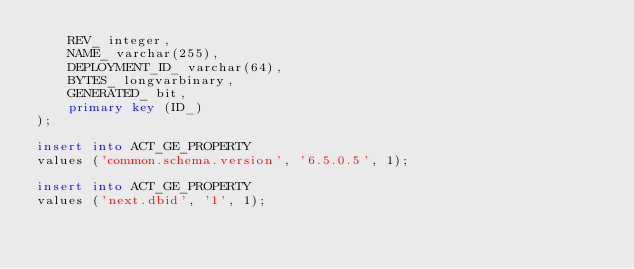<code> <loc_0><loc_0><loc_500><loc_500><_SQL_>    REV_ integer,
    NAME_ varchar(255),
    DEPLOYMENT_ID_ varchar(64),
    BYTES_ longvarbinary,
    GENERATED_ bit,
    primary key (ID_)
);

insert into ACT_GE_PROPERTY
values ('common.schema.version', '6.5.0.5', 1);

insert into ACT_GE_PROPERTY
values ('next.dbid', '1', 1);
</code> 